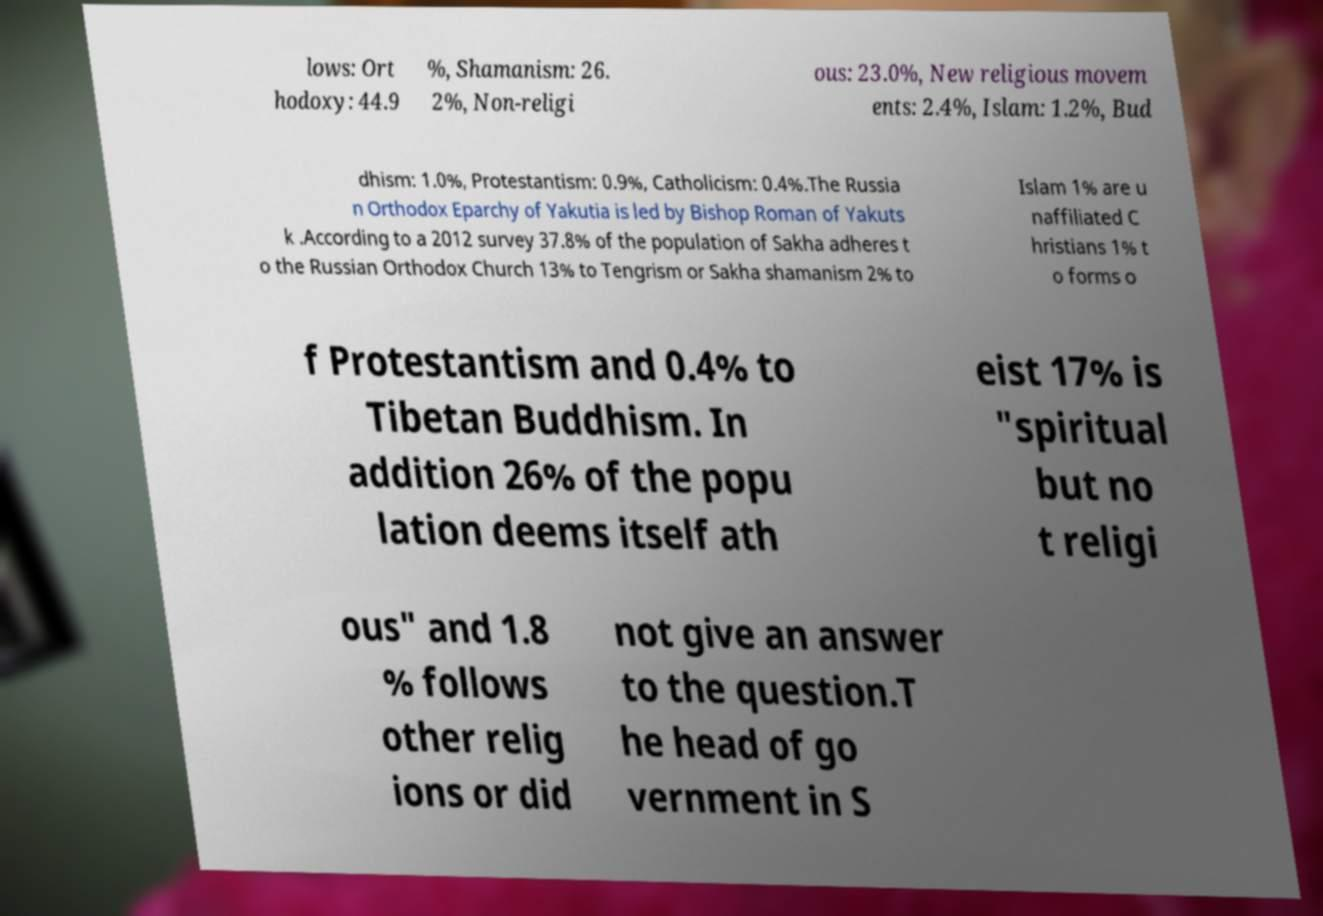Please read and relay the text visible in this image. What does it say? lows: Ort hodoxy: 44.9 %, Shamanism: 26. 2%, Non-religi ous: 23.0%, New religious movem ents: 2.4%, Islam: 1.2%, Bud dhism: 1.0%, Protestantism: 0.9%, Catholicism: 0.4%.The Russia n Orthodox Eparchy of Yakutia is led by Bishop Roman of Yakuts k .According to a 2012 survey 37.8% of the population of Sakha adheres t o the Russian Orthodox Church 13% to Tengrism or Sakha shamanism 2% to Islam 1% are u naffiliated C hristians 1% t o forms o f Protestantism and 0.4% to Tibetan Buddhism. In addition 26% of the popu lation deems itself ath eist 17% is "spiritual but no t religi ous" and 1.8 % follows other relig ions or did not give an answer to the question.T he head of go vernment in S 